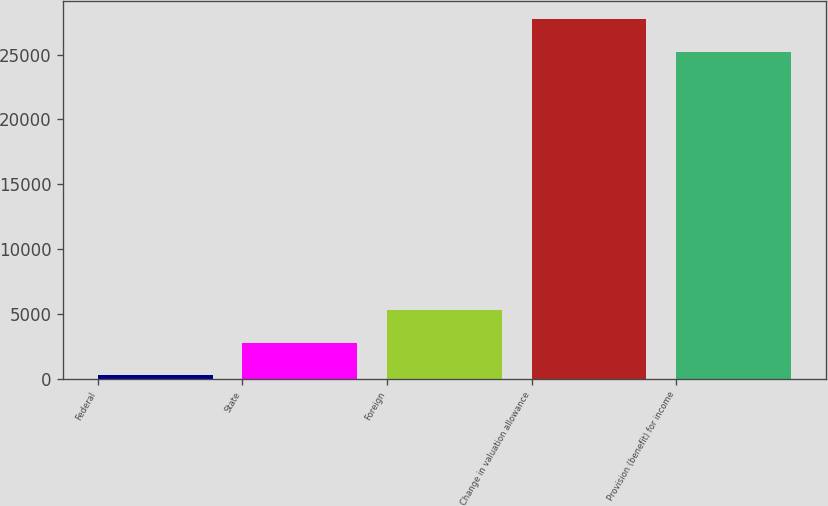<chart> <loc_0><loc_0><loc_500><loc_500><bar_chart><fcel>Federal<fcel>State<fcel>Foreign<fcel>Change in valuation allowance<fcel>Provision (benefit) for income<nl><fcel>251<fcel>2769.5<fcel>5288<fcel>27745.5<fcel>25227<nl></chart> 